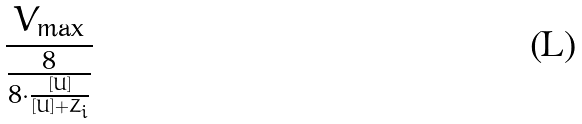Convert formula to latex. <formula><loc_0><loc_0><loc_500><loc_500>\frac { V _ { \max } } { \frac { 8 } { 8 \cdot \frac { [ U ] } { [ U ] + Z _ { i } } } }</formula> 